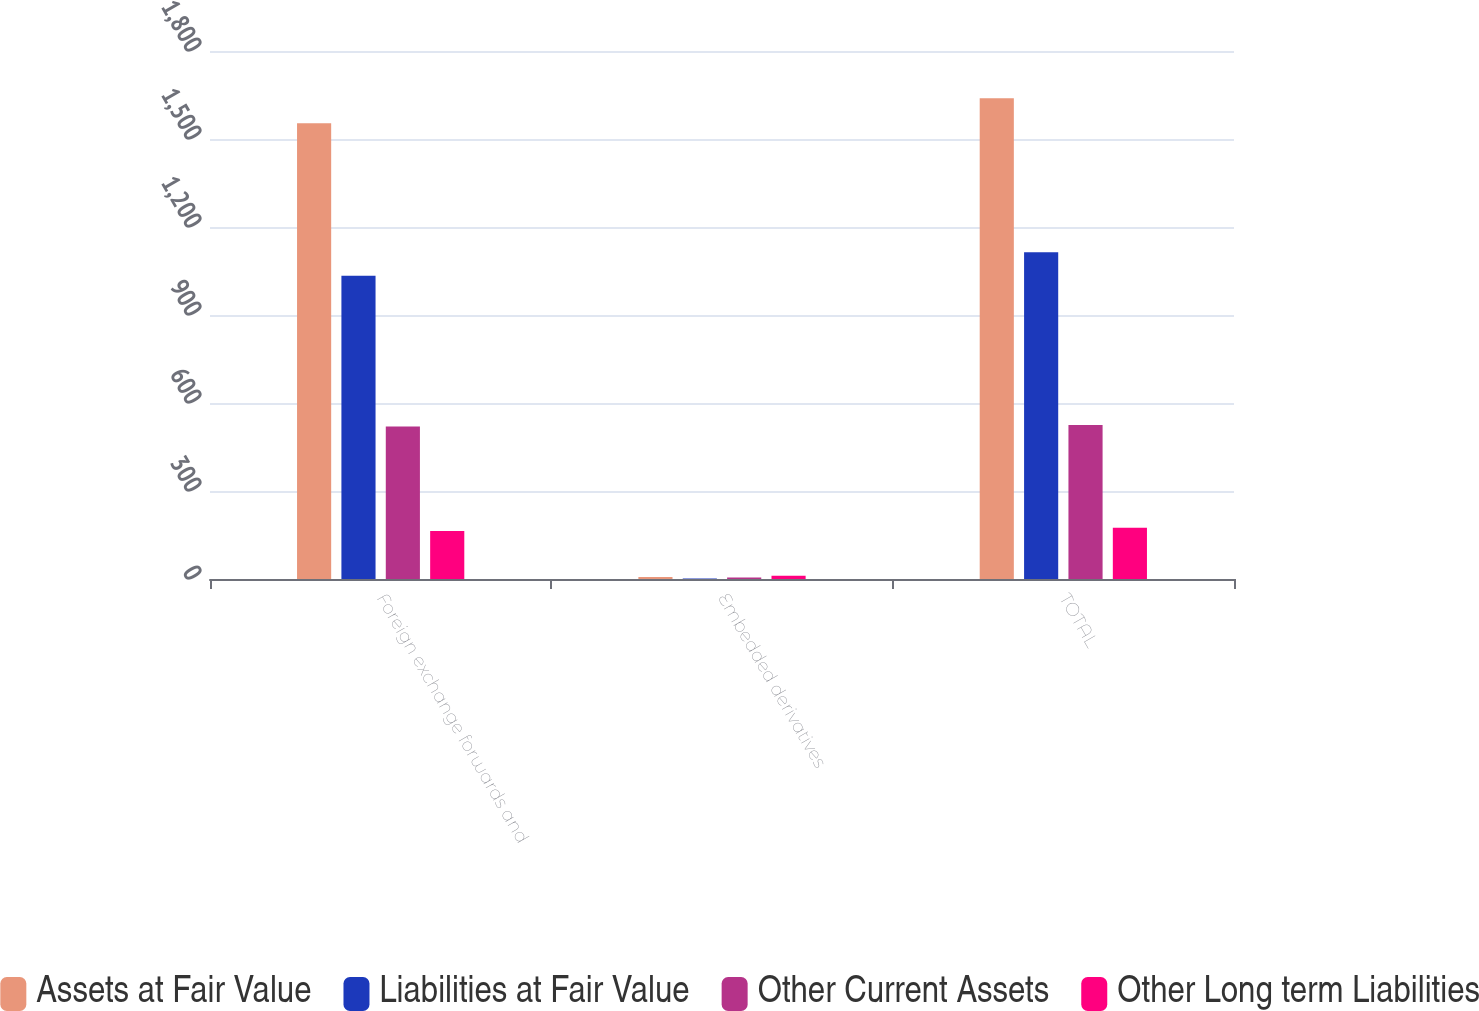Convert chart to OTSL. <chart><loc_0><loc_0><loc_500><loc_500><stacked_bar_chart><ecel><fcel>Foreign exchange forwards and<fcel>Embedded derivatives<fcel>TOTAL<nl><fcel>Assets at Fair Value<fcel>1554<fcel>7<fcel>1639<nl><fcel>Liabilities at Fair Value<fcel>1034<fcel>2<fcel>1114<nl><fcel>Other Current Assets<fcel>520<fcel>5<fcel>525<nl><fcel>Other Long term Liabilities<fcel>164<fcel>11<fcel>175<nl></chart> 